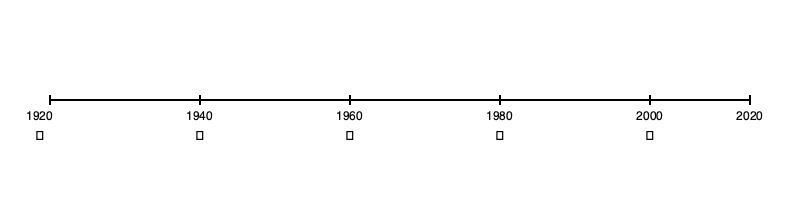Based on the timeline of Southern music evolution, which iconic symbol represents the era when rock 'n' roll emerged and significantly influenced Southern music? To answer this question, we need to analyze the timeline and understand the significance of each symbol in relation to Southern music history:

1. 1920s (🎺): This era is associated with the rise of jazz and blues in the South, particularly in New Orleans.

2. 1940s (🎸): This symbol represents the guitar, which became prominent in the 1940s and early 1950s. This era saw the emergence of rock 'n' roll, which had its roots in Southern rhythm and blues and country music.

3. 1960s (🎤): The microphone symbol likely represents the rise of soul music and the increasing popularity of vocal-driven genres in the South.

4. 1980s (🥁): The drum symbol might represent the influence of hip-hop and electronic music on Southern genres.

5. 2000s (🎧): The headphones symbol could represent the digital age and the rise of home recording and streaming in Southern music.

Rock 'n' roll, which significantly influenced Southern music, emerged in the late 1940s and early 1950s. The guitar symbol (🎸) aligns most closely with this period, representing the instrument that became iconic in rock 'n' roll and its Southern predecessors like rockabilly.
Answer: 🎸 (guitar symbol, 1940s) 